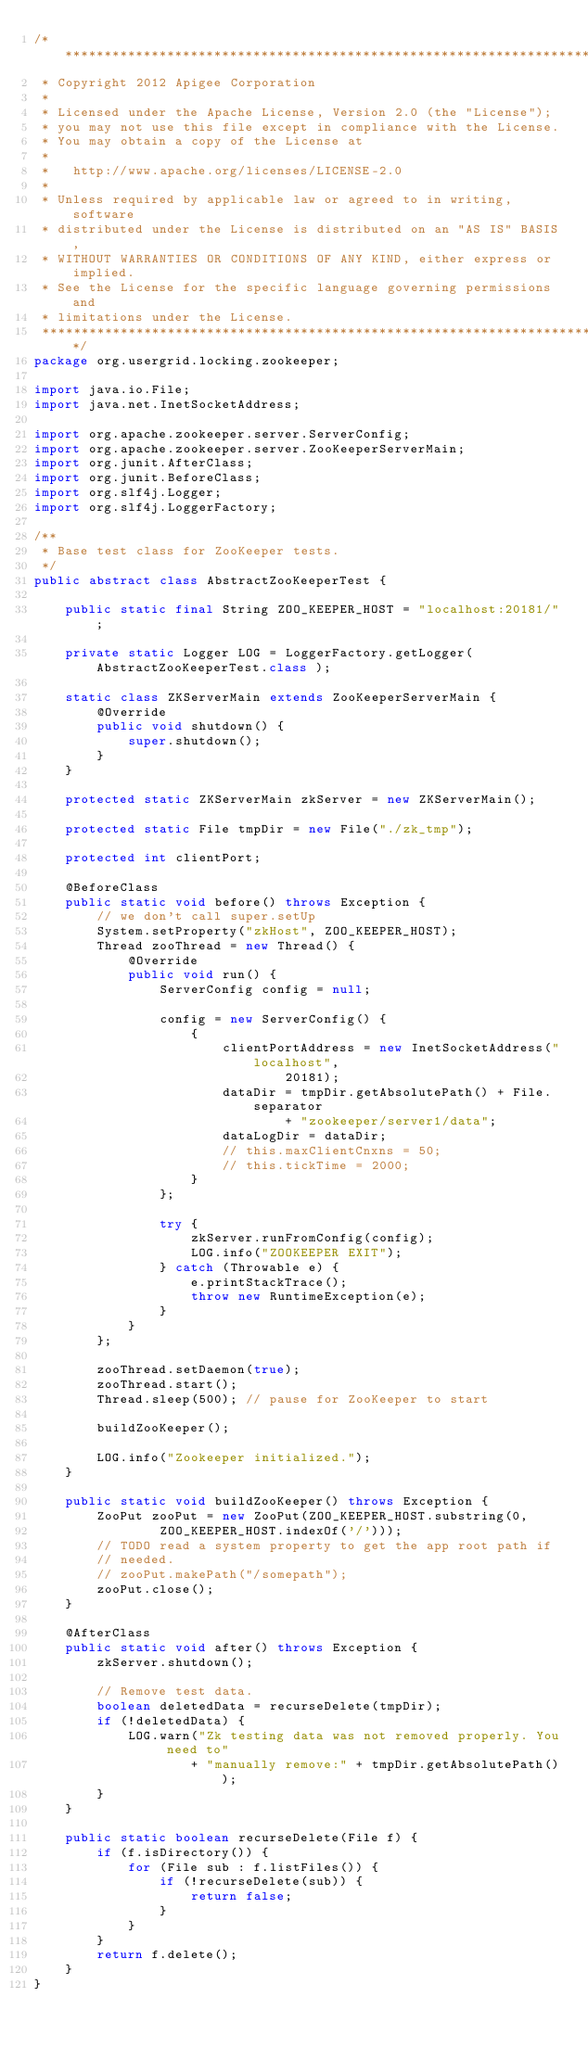<code> <loc_0><loc_0><loc_500><loc_500><_Java_>/*******************************************************************************
 * Copyright 2012 Apigee Corporation
 * 
 * Licensed under the Apache License, Version 2.0 (the "License");
 * you may not use this file except in compliance with the License.
 * You may obtain a copy of the License at
 * 
 *   http://www.apache.org/licenses/LICENSE-2.0
 * 
 * Unless required by applicable law or agreed to in writing, software
 * distributed under the License is distributed on an "AS IS" BASIS,
 * WITHOUT WARRANTIES OR CONDITIONS OF ANY KIND, either express or implied.
 * See the License for the specific language governing permissions and
 * limitations under the License.
 ******************************************************************************/
package org.usergrid.locking.zookeeper;

import java.io.File;
import java.net.InetSocketAddress;

import org.apache.zookeeper.server.ServerConfig;
import org.apache.zookeeper.server.ZooKeeperServerMain;
import org.junit.AfterClass;
import org.junit.BeforeClass;
import org.slf4j.Logger;
import org.slf4j.LoggerFactory;

/**
 * Base test class for ZooKeeper tests.
 */
public abstract class AbstractZooKeeperTest {

	public static final String ZOO_KEEPER_HOST = "localhost:20181/";

	private static Logger LOG = LoggerFactory.getLogger( AbstractZooKeeperTest.class );

	static class ZKServerMain extends ZooKeeperServerMain {
		@Override
		public void shutdown() {
			super.shutdown();
		}
	}

	protected static ZKServerMain zkServer = new ZKServerMain();

	protected static File tmpDir = new File("./zk_tmp");

	protected int clientPort;

	@BeforeClass
	public static void before() throws Exception {
		// we don't call super.setUp
		System.setProperty("zkHost", ZOO_KEEPER_HOST);
		Thread zooThread = new Thread() {
			@Override
			public void run() {
				ServerConfig config = null;

				config = new ServerConfig() {
					{
						clientPortAddress = new InetSocketAddress("localhost",
								20181);
						dataDir = tmpDir.getAbsolutePath() + File.separator
								+ "zookeeper/server1/data";
						dataLogDir = dataDir;
						// this.maxClientCnxns = 50;
						// this.tickTime = 2000;
					}
				};

				try {
					zkServer.runFromConfig(config);
					LOG.info("ZOOKEEPER EXIT");
				} catch (Throwable e) {
					e.printStackTrace();
					throw new RuntimeException(e);
				}
			}
		};

		zooThread.setDaemon(true);
		zooThread.start();
		Thread.sleep(500); // pause for ZooKeeper to start

		buildZooKeeper();

		LOG.info("Zookeeper initialized.");
	}

	public static void buildZooKeeper() throws Exception {
		ZooPut zooPut = new ZooPut(ZOO_KEEPER_HOST.substring(0,
				ZOO_KEEPER_HOST.indexOf('/')));
		// TODO read a system property to get the app root path if
		// needed.
		// zooPut.makePath("/somepath");
		zooPut.close();
	}

	@AfterClass
	public static void after() throws Exception {
		zkServer.shutdown();

		// Remove test data.
		boolean deletedData = recurseDelete(tmpDir);
		if (!deletedData) {
			LOG.warn("Zk testing data was not removed properly. You need to"
                    + "manually remove:" + tmpDir.getAbsolutePath());
		}
	}

	public static boolean recurseDelete(File f) {
		if (f.isDirectory()) {
			for (File sub : f.listFiles()) {
				if (!recurseDelete(sub)) {
					return false;
				}
			}
		}
		return f.delete();
	}
}
</code> 